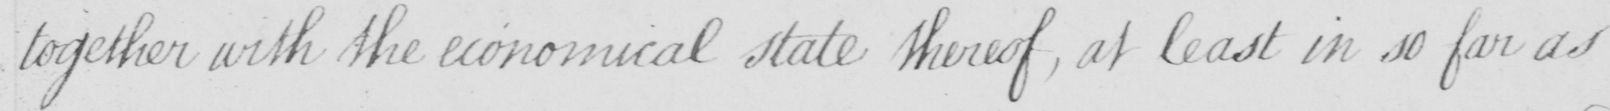Please transcribe the handwritten text in this image. together with the economical state thereof  , at least in so far as 